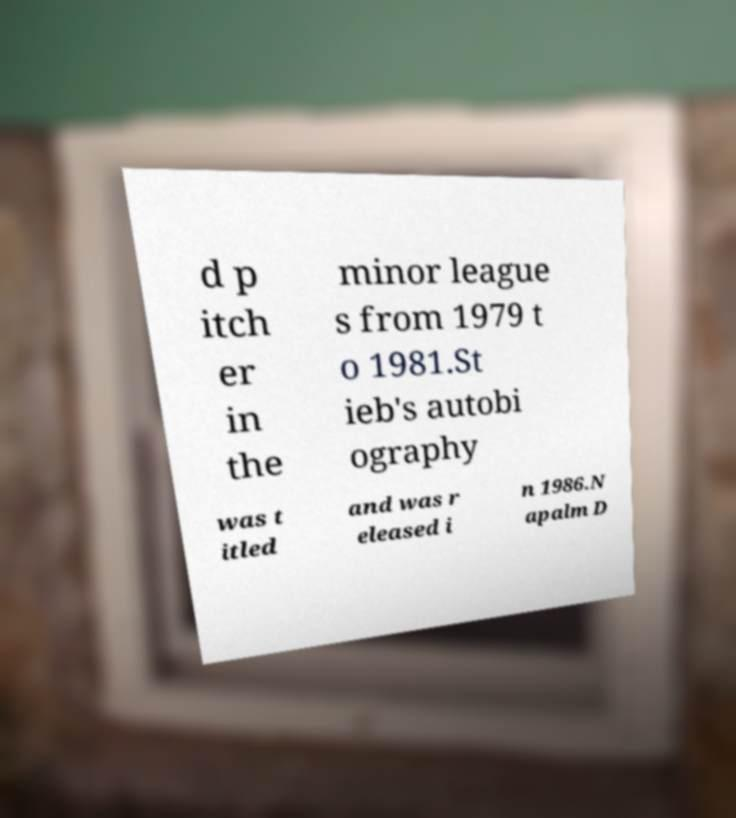I need the written content from this picture converted into text. Can you do that? d p itch er in the minor league s from 1979 t o 1981.St ieb's autobi ography was t itled and was r eleased i n 1986.N apalm D 